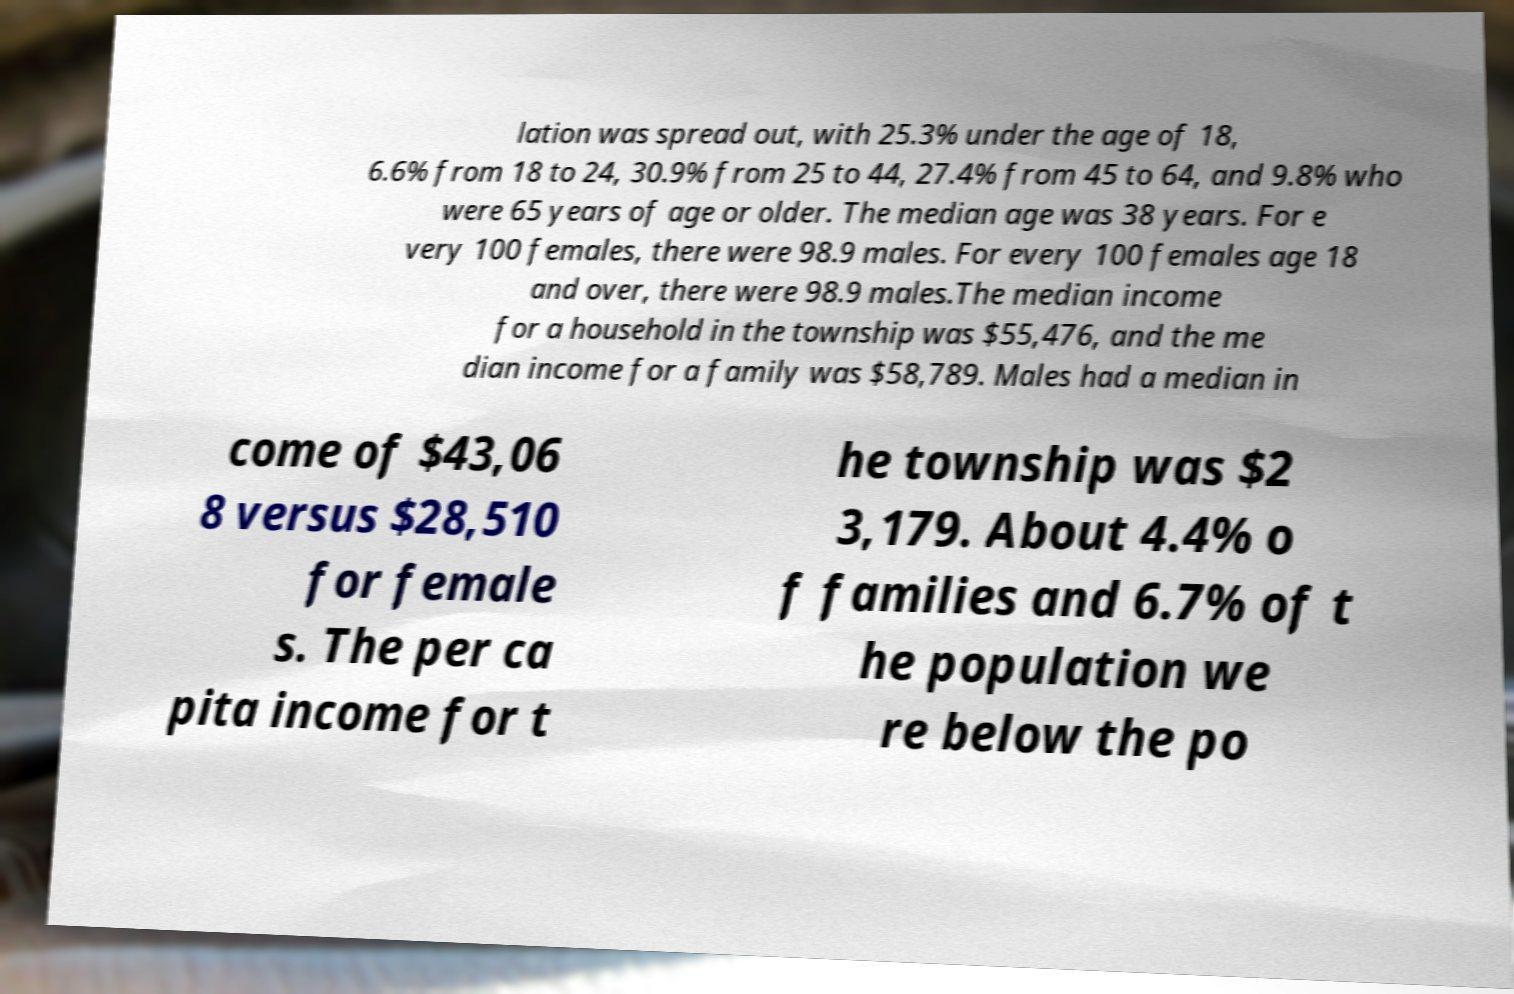Can you read and provide the text displayed in the image?This photo seems to have some interesting text. Can you extract and type it out for me? lation was spread out, with 25.3% under the age of 18, 6.6% from 18 to 24, 30.9% from 25 to 44, 27.4% from 45 to 64, and 9.8% who were 65 years of age or older. The median age was 38 years. For e very 100 females, there were 98.9 males. For every 100 females age 18 and over, there were 98.9 males.The median income for a household in the township was $55,476, and the me dian income for a family was $58,789. Males had a median in come of $43,06 8 versus $28,510 for female s. The per ca pita income for t he township was $2 3,179. About 4.4% o f families and 6.7% of t he population we re below the po 